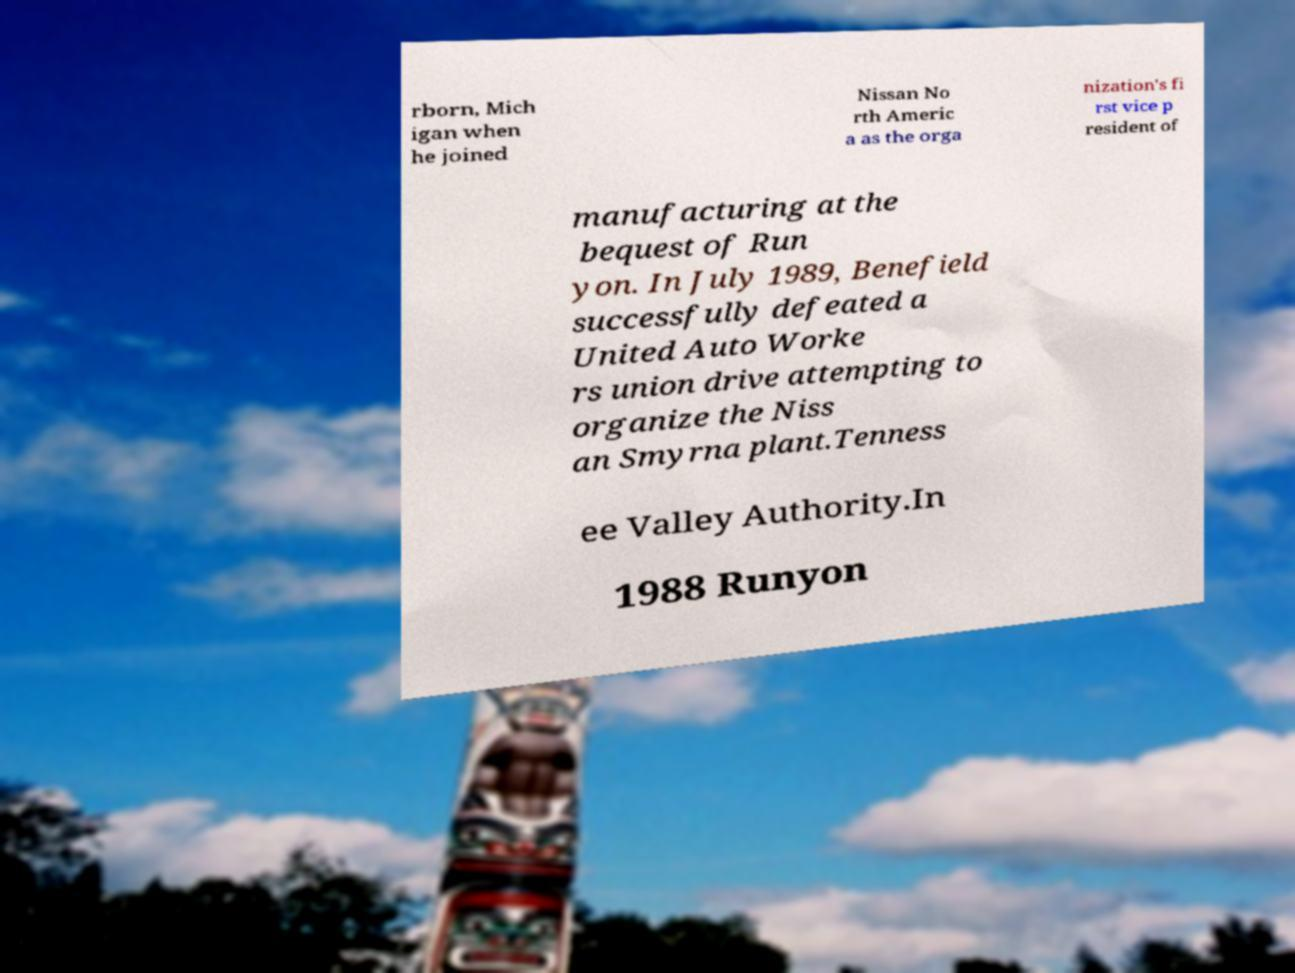What messages or text are displayed in this image? I need them in a readable, typed format. rborn, Mich igan when he joined Nissan No rth Americ a as the orga nization's fi rst vice p resident of manufacturing at the bequest of Run yon. In July 1989, Benefield successfully defeated a United Auto Worke rs union drive attempting to organize the Niss an Smyrna plant.Tenness ee Valley Authority.In 1988 Runyon 